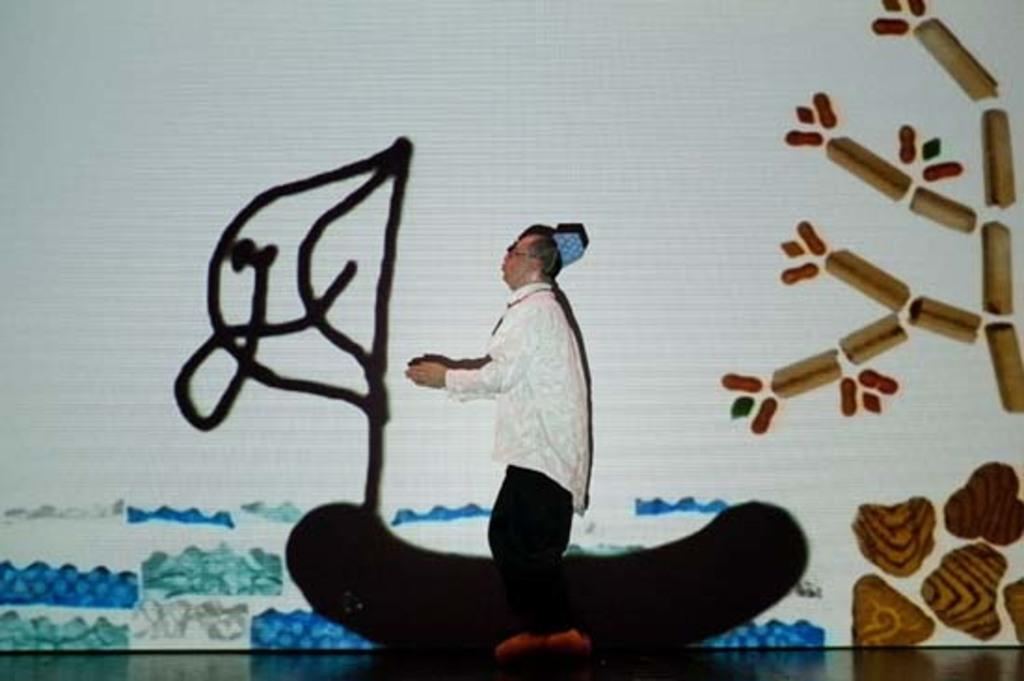What is the main subject of the image? The main subject of the image is a person standing on a stage. What else can be seen in the image besides the person on the stage? There is a painting on a whiteboard in the image. What type of fang can be seen in the image? There is no fang present in the image. What kind of machine is being used by the person on the stage? The image does not show any machines being used by the person on the stage. 